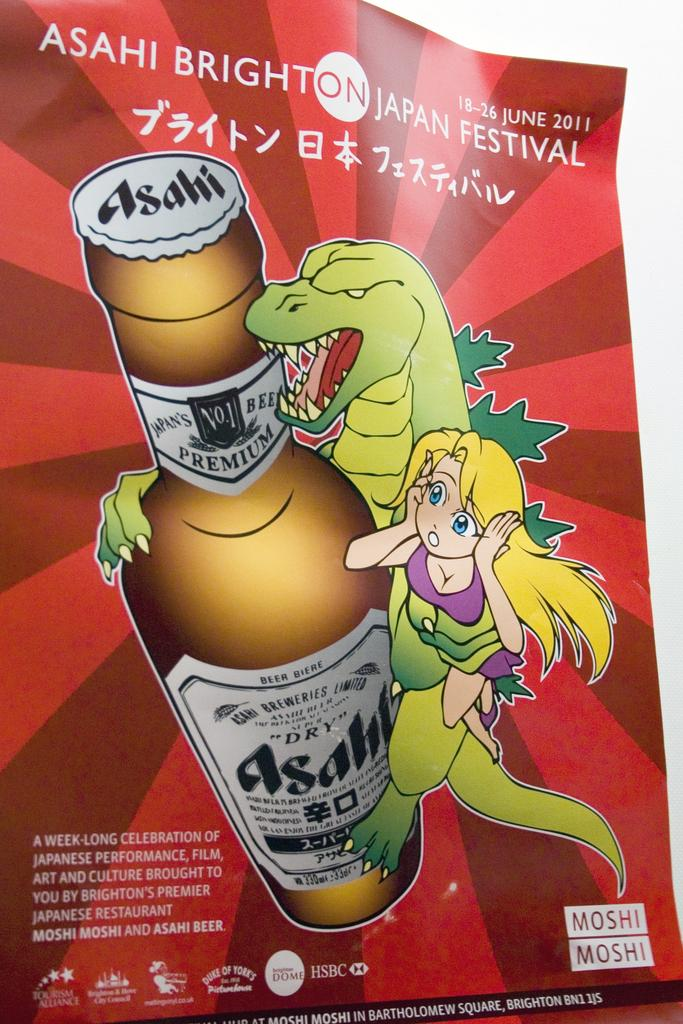What is present on the paper in the image? The paper has logos, words, numbers, and a picture on it. What is the paper placed on in the image? The paper is on an object in the image. Can you describe the content of the paper? The paper contains logos, words, numbers, and a picture. What type of prose can be found in the drawer in the image? There is no drawer or prose present in the image. What type of machine is depicted in the picture on the paper? The image on the paper does not depict a machine; it is not mentioned in the provided facts. 